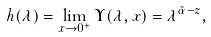<formula> <loc_0><loc_0><loc_500><loc_500>h ( \lambda ) = \lim _ { x \to 0 ^ { + } } \Upsilon ( \lambda , x ) = \lambda ^ { \tilde { \alpha } - z } ,</formula> 